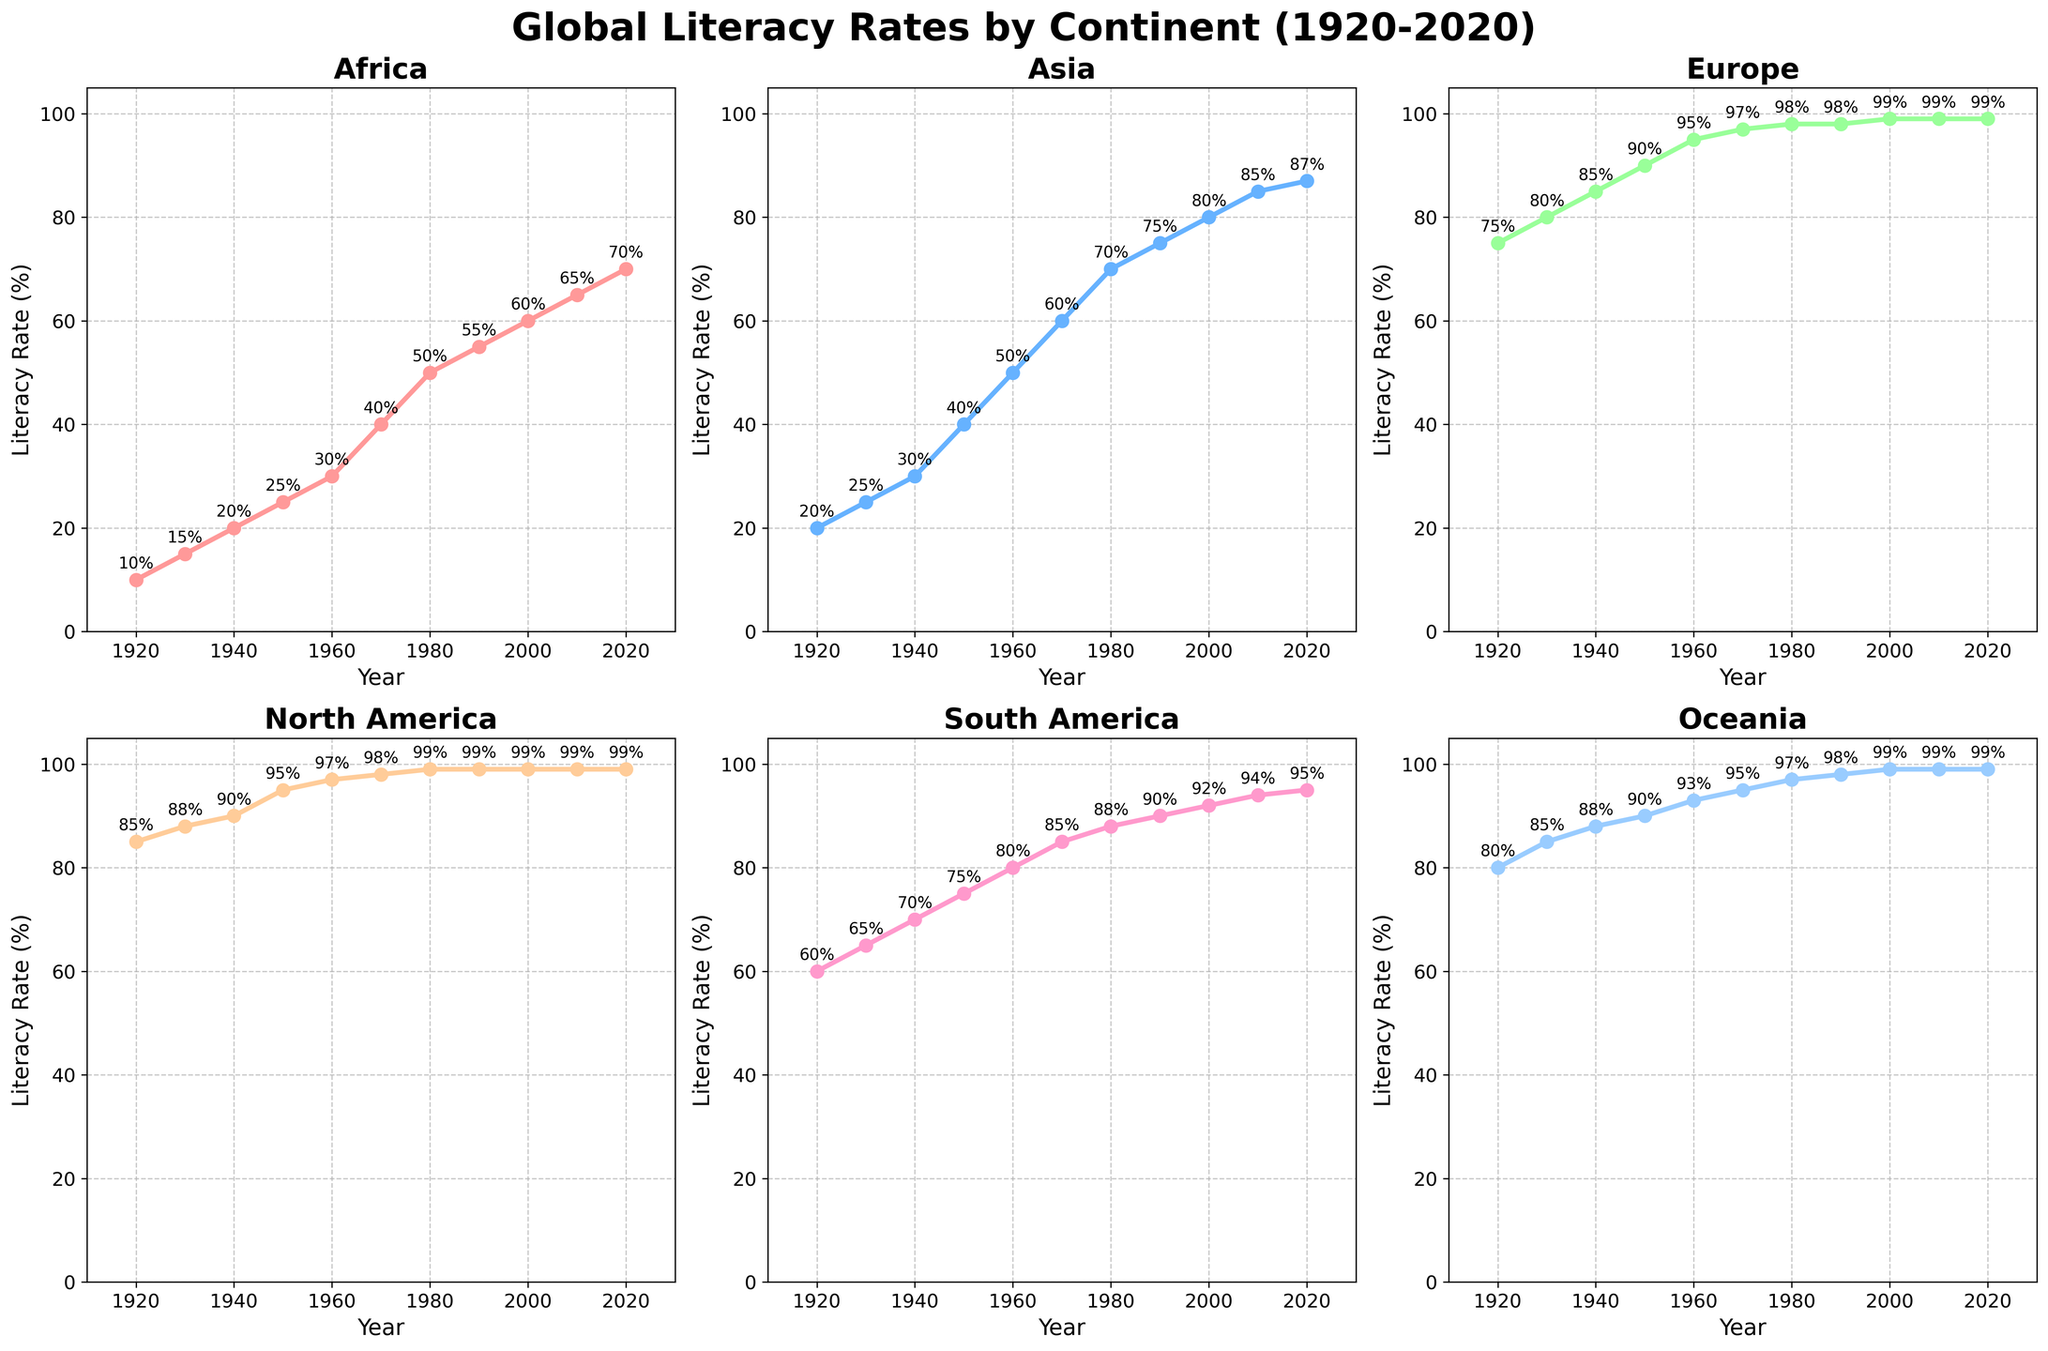How has the literacy rate in Asia changed from 1920 to 2020? To find the change, look at the literacy rate for Asia in 1920, which is 20%, and in 2020, which is 87%. The change is 87% - 20% = 67%.
Answer: 67% Which continent had the highest literacy rate in 1950? Look at the 1950 data for all continents. Europe had the highest literacy rate at 90%.
Answer: Europe In which year did Africa's literacy rate reach 50%? Look at the literacy rates for Africa and find the first year where it reached 50%. In 1980, Africa's literacy rate was 50%.
Answer: 1980 Compare the literacy rate of North America and South America in 1940. Which was higher and by how much? In 1940, North America's literacy rate was 90% and South America's was 70%. The difference is 90% - 70% = 20%.
Answer: North America, 20% What is the average literacy rate for Oceania from 1920 to 2020? Add the literacy rates for Oceania over these years and divide by the number of years (11). The sum is 80 + 85 + 88 + 90 + 93 + 95 + 97 + 98 + 99 + 99 + 99 = 923; the average is 923 / 11 ≈ 83.91%.
Answer: 83.91% By how many percentage points did South America's literacy rate increase between 1980 and 2010? In 1980, South America's literacy rate was 88%, and in 2010, it was 94%. The increase is 94% - 88% = 6%.
Answer: 6% Which continent had the most significant increase in literacy rates between 1920 and 2020? Calculate the increase for each continent: 
- Africa: 70% - 10% = 60%
- Asia: 87% - 20% = 67%
- Europe: 99% - 75% = 24%
- North America: 99% - 85% = 14%
- South America: 95% - 60% = 35%
- Oceania: 99% - 80% = 19%
Asia had the most significant increase with 67%.
Answer: Asia In which decade did Europe reach a nearly perfect literacy rate of 99%? Look at Europe's literacy rates over the years. Europe reached 99% in 2000.
Answer: 2000s What is the overall trend in literacy rates for Africa from 1920 to 2020? Observing the data for Africa from 1920 to 2020 shows a consistent upward trend, starting at 10% in 1920 and reaching 70% in 2020.
Answer: Upward trend Compare the literacy rates of Asia and Oceania in 2020. Are they equal or different? In 2020, Asia’s literacy rate is 87%, and Oceania’s literacy rate is 99%. They are different.
Answer: Different Which continent had the least variation in literacy rates from 1920 to 2020? Calculate the range (highest - lowest rate) for each continent:
- Africa: 70% - 10% = 60%
- Asia: 87% - 20% = 67%
- Europe: 99% - 75% = 24%
- North America: 99% - 85% = 14%
- South America: 95% - 60% = 35%
- Oceania: 99% - 80% = 19%
North America had the least variation with 14%.
Answer: North America 